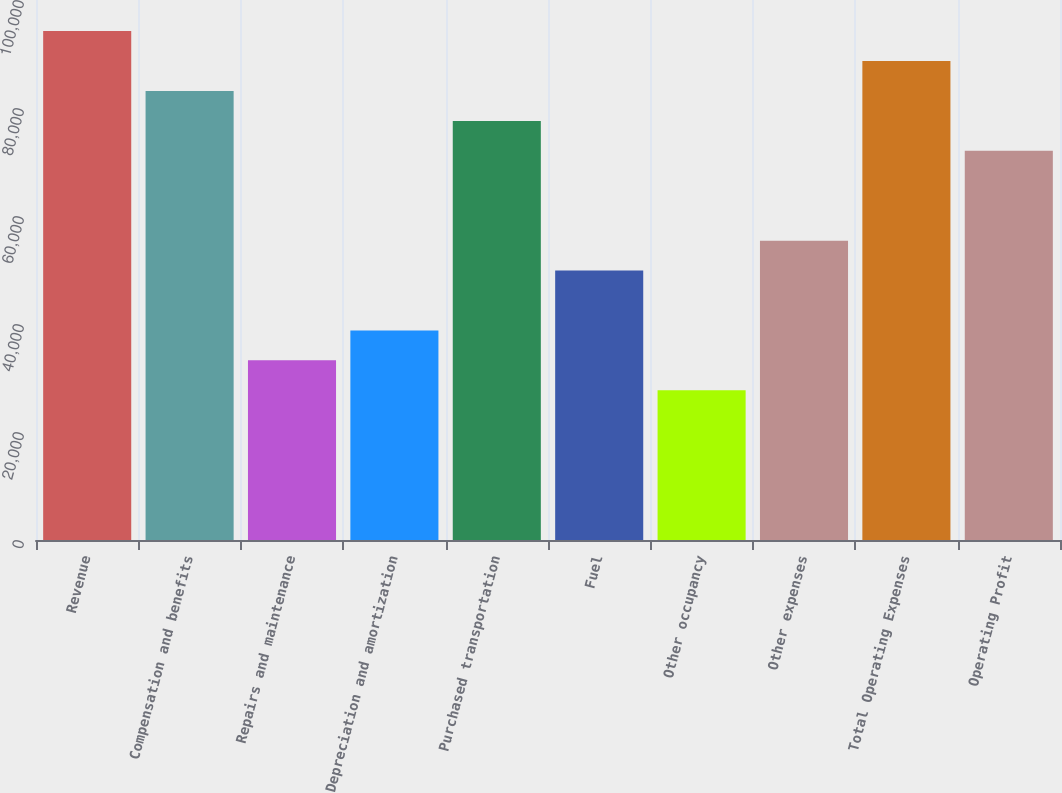Convert chart to OTSL. <chart><loc_0><loc_0><loc_500><loc_500><bar_chart><fcel>Revenue<fcel>Compensation and benefits<fcel>Repairs and maintenance<fcel>Depreciation and amortization<fcel>Purchased transportation<fcel>Fuel<fcel>Other occupancy<fcel>Other expenses<fcel>Total Operating Expenses<fcel>Operating Profit<nl><fcel>94241.4<fcel>83154.7<fcel>33264.7<fcel>38808<fcel>77611.4<fcel>49894.7<fcel>27721.3<fcel>55438<fcel>88698.1<fcel>72068<nl></chart> 